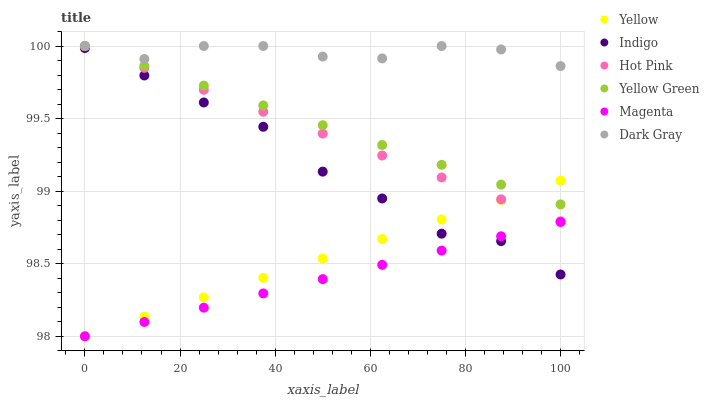Does Magenta have the minimum area under the curve?
Answer yes or no. Yes. Does Dark Gray have the maximum area under the curve?
Answer yes or no. Yes. Does Yellow Green have the minimum area under the curve?
Answer yes or no. No. Does Yellow Green have the maximum area under the curve?
Answer yes or no. No. Is Hot Pink the smoothest?
Answer yes or no. Yes. Is Indigo the roughest?
Answer yes or no. Yes. Is Yellow Green the smoothest?
Answer yes or no. No. Is Yellow Green the roughest?
Answer yes or no. No. Does Yellow have the lowest value?
Answer yes or no. Yes. Does Yellow Green have the lowest value?
Answer yes or no. No. Does Dark Gray have the highest value?
Answer yes or no. Yes. Does Yellow have the highest value?
Answer yes or no. No. Is Yellow less than Dark Gray?
Answer yes or no. Yes. Is Dark Gray greater than Magenta?
Answer yes or no. Yes. Does Indigo intersect Yellow?
Answer yes or no. Yes. Is Indigo less than Yellow?
Answer yes or no. No. Is Indigo greater than Yellow?
Answer yes or no. No. Does Yellow intersect Dark Gray?
Answer yes or no. No. 